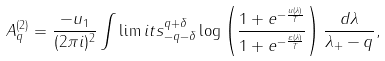Convert formula to latex. <formula><loc_0><loc_0><loc_500><loc_500>A _ { q } ^ { ( 2 ) } = \frac { - u _ { 1 } } { ( 2 \pi i ) ^ { 2 } } \int \lim i t s _ { - q - \delta } ^ { q + \delta } \log \left ( \frac { 1 + e ^ { - \frac { u ( \lambda ) } T } } { 1 + e ^ { - \frac { \varepsilon ( \lambda ) } T } } \right ) \frac { d \lambda } { \lambda _ { + } - q } ,</formula> 